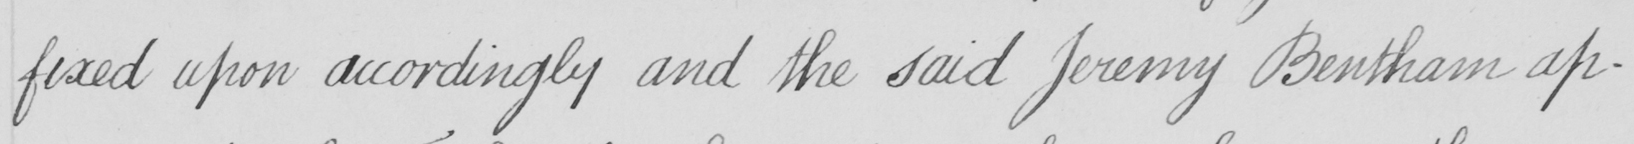Transcribe the text shown in this historical manuscript line. fixed upon accordingly and the said Jeremy Bentham ap- 